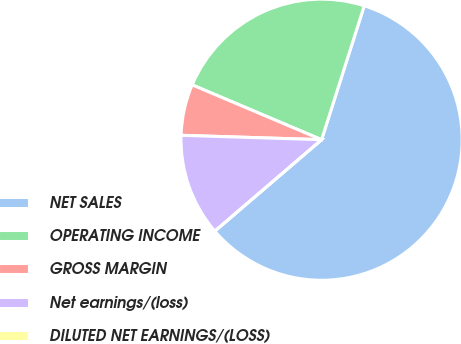Convert chart. <chart><loc_0><loc_0><loc_500><loc_500><pie_chart><fcel>NET SALES<fcel>OPERATING INCOME<fcel>GROSS MARGIN<fcel>Net earnings/(loss)<fcel>DILUTED NET EARNINGS/(LOSS)<nl><fcel>58.82%<fcel>23.53%<fcel>5.88%<fcel>11.77%<fcel>0.0%<nl></chart> 